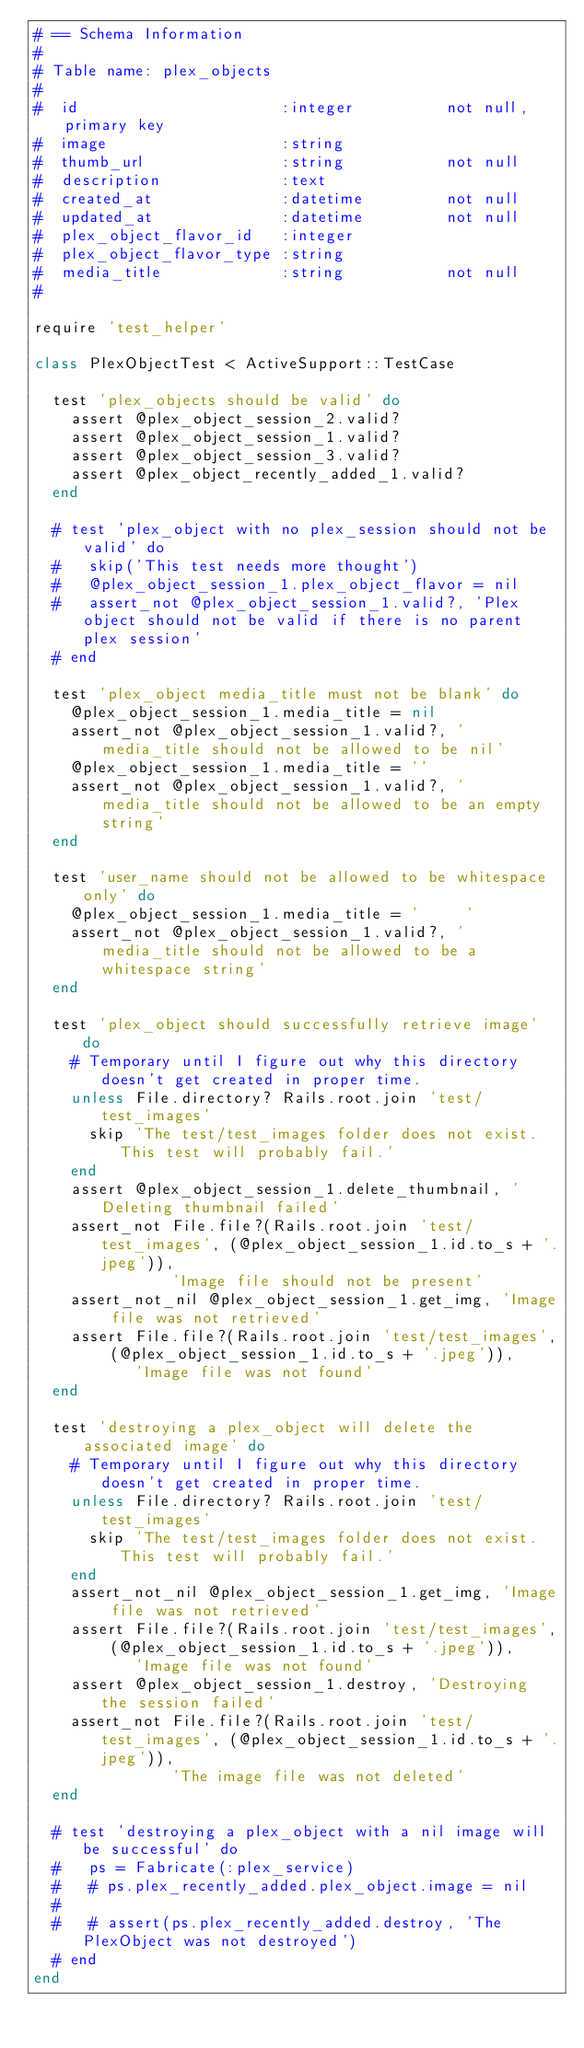<code> <loc_0><loc_0><loc_500><loc_500><_Ruby_># == Schema Information
#
# Table name: plex_objects
#
#  id                      :integer          not null, primary key
#  image                   :string
#  thumb_url               :string           not null
#  description             :text
#  created_at              :datetime         not null
#  updated_at              :datetime         not null
#  plex_object_flavor_id   :integer
#  plex_object_flavor_type :string
#  media_title             :string           not null
#

require 'test_helper'

class PlexObjectTest < ActiveSupport::TestCase

  test 'plex_objects should be valid' do
    assert @plex_object_session_2.valid?
    assert @plex_object_session_1.valid?
    assert @plex_object_session_3.valid?
    assert @plex_object_recently_added_1.valid?
  end

  # test 'plex_object with no plex_session should not be valid' do
  #   skip('This test needs more thought')
  #   @plex_object_session_1.plex_object_flavor = nil
  #   assert_not @plex_object_session_1.valid?, 'Plex object should not be valid if there is no parent plex session'
  # end

  test 'plex_object media_title must not be blank' do
    @plex_object_session_1.media_title = nil
    assert_not @plex_object_session_1.valid?, 'media_title should not be allowed to be nil'
    @plex_object_session_1.media_title = ''
    assert_not @plex_object_session_1.valid?, 'media_title should not be allowed to be an empty string'
  end

  test 'user_name should not be allowed to be whitespace only' do
    @plex_object_session_1.media_title = '     '
    assert_not @plex_object_session_1.valid?, 'media_title should not be allowed to be a whitespace string'
  end

  test 'plex_object should successfully retrieve image' do
    # Temporary until I figure out why this directory doesn't get created in proper time.
    unless File.directory? Rails.root.join 'test/test_images'
      skip 'The test/test_images folder does not exist. This test will probably fail.'
    end
    assert @plex_object_session_1.delete_thumbnail, 'Deleting thumbnail failed'
    assert_not File.file?(Rails.root.join 'test/test_images', (@plex_object_session_1.id.to_s + '.jpeg')),
               'Image file should not be present'
    assert_not_nil @plex_object_session_1.get_img, 'Image file was not retrieved'
    assert File.file?(Rails.root.join 'test/test_images', (@plex_object_session_1.id.to_s + '.jpeg')),
           'Image file was not found'
  end

  test 'destroying a plex_object will delete the associated image' do
    # Temporary until I figure out why this directory doesn't get created in proper time.
    unless File.directory? Rails.root.join 'test/test_images'
      skip 'The test/test_images folder does not exist. This test will probably fail.'
    end
    assert_not_nil @plex_object_session_1.get_img, 'Image file was not retrieved'
    assert File.file?(Rails.root.join 'test/test_images', (@plex_object_session_1.id.to_s + '.jpeg')),
           'Image file was not found'
    assert @plex_object_session_1.destroy, 'Destroying the session failed'
    assert_not File.file?(Rails.root.join 'test/test_images', (@plex_object_session_1.id.to_s + '.jpeg')),
               'The image file was not deleted'
  end

  # test 'destroying a plex_object with a nil image will be successful' do
  #   ps = Fabricate(:plex_service)
  #   # ps.plex_recently_added.plex_object.image = nil
  #
  #   # assert(ps.plex_recently_added.destroy, 'The PlexObject was not destroyed')
  # end
end
</code> 